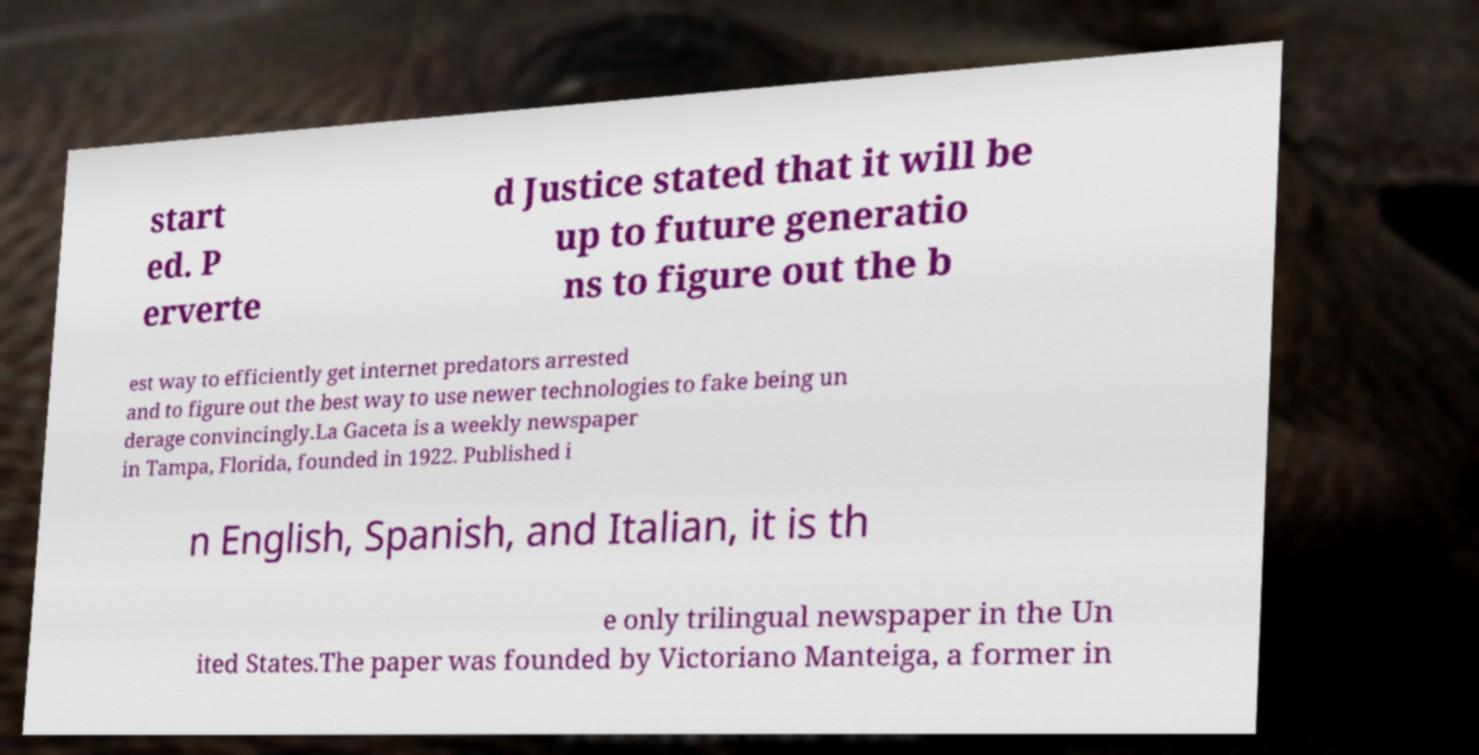For documentation purposes, I need the text within this image transcribed. Could you provide that? start ed. P erverte d Justice stated that it will be up to future generatio ns to figure out the b est way to efficiently get internet predators arrested and to figure out the best way to use newer technologies to fake being un derage convincingly.La Gaceta is a weekly newspaper in Tampa, Florida, founded in 1922. Published i n English, Spanish, and Italian, it is th e only trilingual newspaper in the Un ited States.The paper was founded by Victoriano Manteiga, a former in 